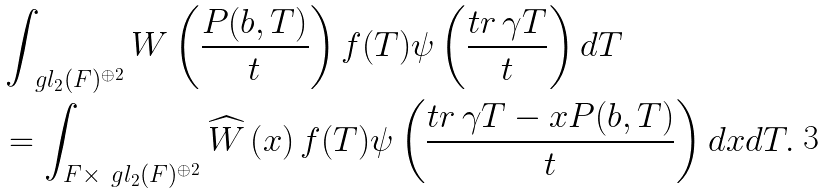<formula> <loc_0><loc_0><loc_500><loc_500>& \int _ { \ g l _ { 2 } ( F ) ^ { \oplus 2 } } W \left ( \frac { P ( b , T ) } { t } \right ) f ( T ) \psi \left ( \frac { t r \, \gamma T } { t } \right ) d T \\ & = \int _ { F \times \ g l _ { 2 } ( F ) ^ { \oplus 2 } } \widehat { W } \left ( x \right ) f ( T ) \psi \left ( \frac { t r \, \gamma T - x P ( b , T ) } { t } \right ) d x d T .</formula> 